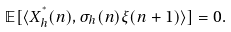<formula> <loc_0><loc_0><loc_500><loc_500>\mathbb { E } [ \langle X _ { h } ^ { ^ { * } } ( n ) , \sigma _ { h } ( n ) \xi ( n + 1 ) \rangle ] = 0 .</formula> 